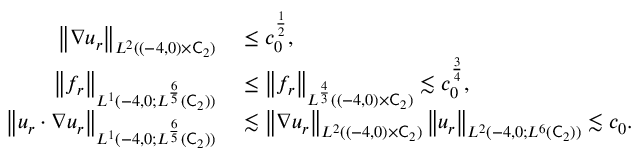Convert formula to latex. <formula><loc_0><loc_0><loc_500><loc_500>\begin{array} { r l } { \left \| \nabla u _ { r } \right \| _ { L ^ { 2 } ( ( - 4 , 0 ) \times \mathsf C _ { 2 } ) } } & \leq c _ { 0 } ^ { \frac { 1 } { 2 } } , } \\ { \left \| f _ { r } \right \| _ { L ^ { 1 } ( - 4 , 0 ; L ^ { \frac { 6 } { 5 } } ( \mathsf C _ { 2 } ) ) } } & \leq \left \| f _ { r } \right \| _ { L ^ { \frac { 4 } { 3 } } ( ( - 4 , 0 ) \times \mathsf C _ { 2 } ) } \lesssim c _ { 0 } ^ { \frac { 3 } { 4 } } , } \\ { \left \| u _ { r } \cdot \nabla u _ { r } \right \| _ { L ^ { 1 } ( - 4 , 0 ; L ^ { \frac { 6 } { 5 } } ( \mathsf C _ { 2 } ) ) } } & \lesssim \left \| \nabla u _ { r } \right \| _ { L ^ { 2 } ( ( - 4 , 0 ) \times \mathsf C _ { 2 } ) } \left \| u _ { r } \right \| _ { L ^ { 2 } ( - 4 , 0 ; L ^ { 6 } ( \mathsf C _ { 2 } ) ) } \lesssim c _ { 0 } . } \end{array}</formula> 